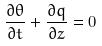Convert formula to latex. <formula><loc_0><loc_0><loc_500><loc_500>\frac { \partial \theta } { \partial t } + \frac { \partial q } { \partial z } = 0</formula> 